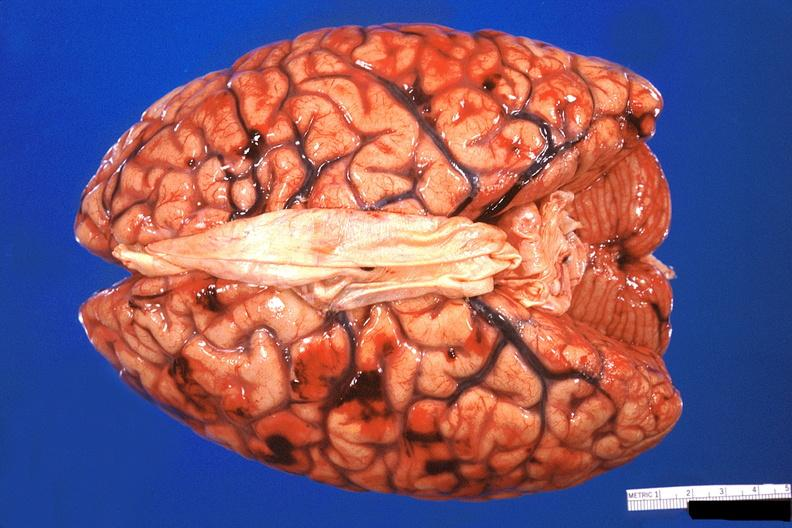what does this image show?
Answer the question using a single word or phrase. Brain 